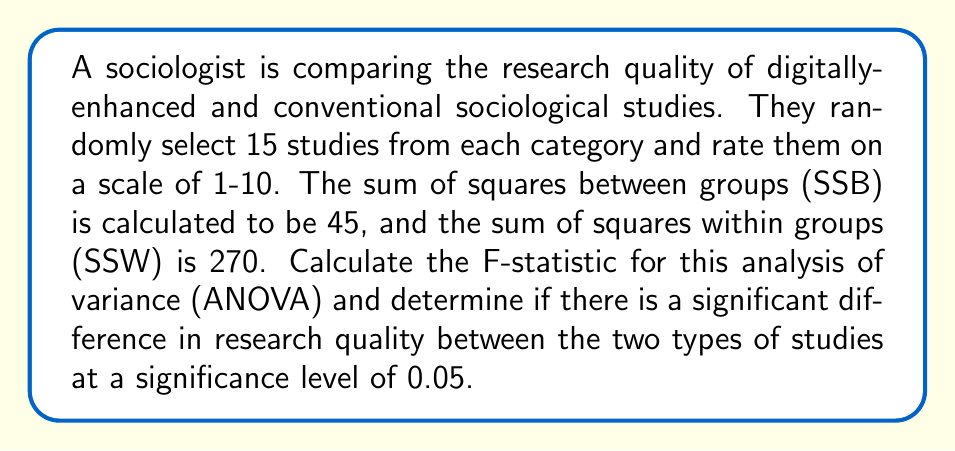Give your solution to this math problem. To calculate the F-statistic and determine if there's a significant difference, we'll follow these steps:

1. Calculate degrees of freedom:
   - Between groups: $df_b = k - 1 = 2 - 1 = 1$ (where k is the number of groups)
   - Within groups: $df_w = N - k = (15 + 15) - 2 = 28$ (where N is the total number of observations)

2. Calculate Mean Square Between (MSB) and Mean Square Within (MSW):
   $$MSB = \frac{SSB}{df_b} = \frac{45}{1} = 45$$
   $$MSW = \frac{SSW}{df_w} = \frac{270}{28} = 9.64286$$

3. Calculate the F-statistic:
   $$F = \frac{MSB}{MSW} = \frac{45}{9.64286} = 4.6667$$

4. Determine the critical F-value:
   For $\alpha = 0.05$, $df_b = 1$, and $df_w = 28$, the critical F-value is approximately 4.20 (from an F-distribution table).

5. Compare the calculated F-statistic to the critical F-value:
   Since 4.6667 > 4.20, we reject the null hypothesis.

Therefore, there is a significant difference in research quality between digitally-enhanced and conventional sociological studies at the 0.05 significance level.
Answer: F-statistic = 4.6667; There is a significant difference in research quality between the two types of studies (p < 0.05). 